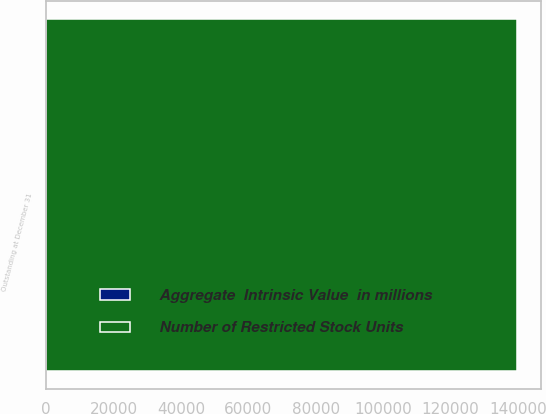Convert chart to OTSL. <chart><loc_0><loc_0><loc_500><loc_500><stacked_bar_chart><ecel><fcel>Outstanding at December 31<nl><fcel>Number of Restricted Stock Units<fcel>139774<nl><fcel>Aggregate  Intrinsic Value  in millions<fcel>20.6<nl></chart> 